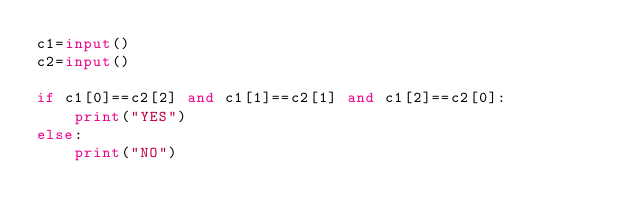<code> <loc_0><loc_0><loc_500><loc_500><_Python_>c1=input()
c2=input()

if c1[0]==c2[2] and c1[1]==c2[1] and c1[2]==c2[0]:
    print("YES")
else:
    print("NO")
</code> 